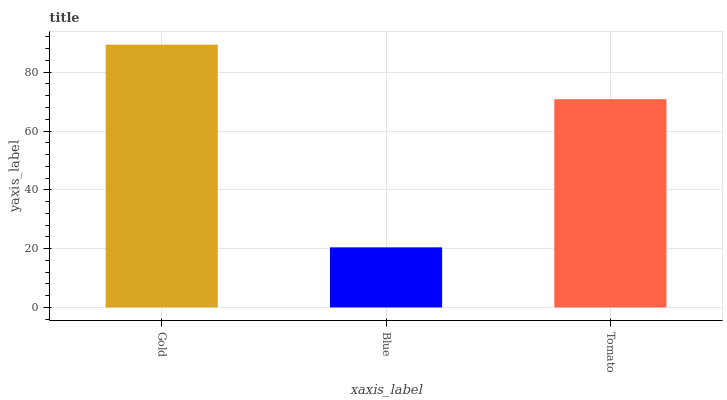Is Blue the minimum?
Answer yes or no. Yes. Is Gold the maximum?
Answer yes or no. Yes. Is Tomato the minimum?
Answer yes or no. No. Is Tomato the maximum?
Answer yes or no. No. Is Tomato greater than Blue?
Answer yes or no. Yes. Is Blue less than Tomato?
Answer yes or no. Yes. Is Blue greater than Tomato?
Answer yes or no. No. Is Tomato less than Blue?
Answer yes or no. No. Is Tomato the high median?
Answer yes or no. Yes. Is Tomato the low median?
Answer yes or no. Yes. Is Gold the high median?
Answer yes or no. No. Is Gold the low median?
Answer yes or no. No. 